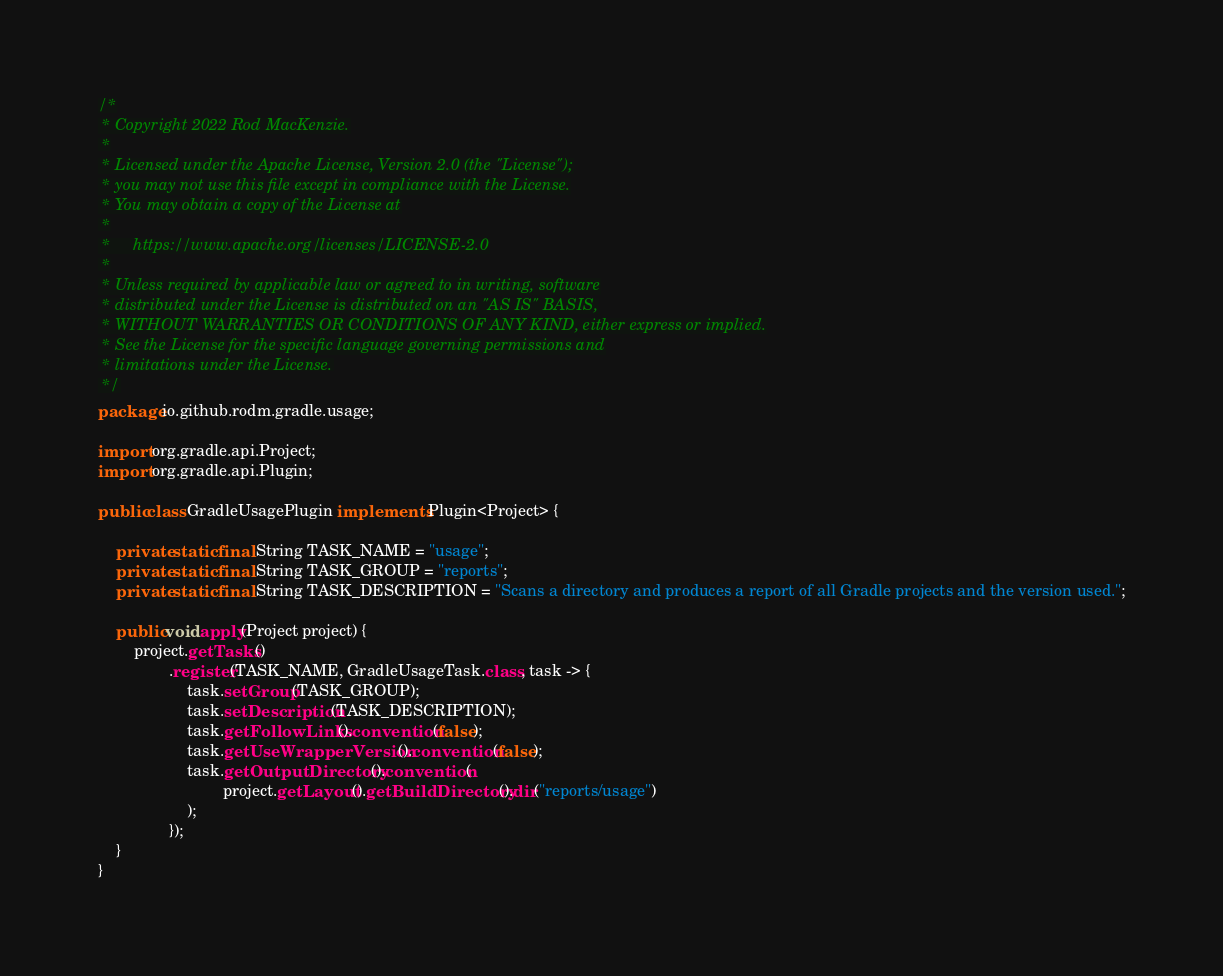Convert code to text. <code><loc_0><loc_0><loc_500><loc_500><_Java_>/*
 * Copyright 2022 Rod MacKenzie.
 *
 * Licensed under the Apache License, Version 2.0 (the "License");
 * you may not use this file except in compliance with the License.
 * You may obtain a copy of the License at
 *
 *     https://www.apache.org/licenses/LICENSE-2.0
 *
 * Unless required by applicable law or agreed to in writing, software
 * distributed under the License is distributed on an "AS IS" BASIS,
 * WITHOUT WARRANTIES OR CONDITIONS OF ANY KIND, either express or implied.
 * See the License for the specific language governing permissions and
 * limitations under the License.
 */
package io.github.rodm.gradle.usage;

import org.gradle.api.Project;
import org.gradle.api.Plugin;

public class GradleUsagePlugin implements Plugin<Project> {

    private static final String TASK_NAME = "usage";
    private static final String TASK_GROUP = "reports";
    private static final String TASK_DESCRIPTION = "Scans a directory and produces a report of all Gradle projects and the version used.";

    public void apply(Project project) {
        project.getTasks()
                .register(TASK_NAME, GradleUsageTask.class, task -> {
                    task.setGroup(TASK_GROUP);
                    task.setDescription(TASK_DESCRIPTION);
                    task.getFollowLinks().convention(false);
                    task.getUseWrapperVersion().convention(false);
                    task.getOutputDirectory().convention(
                            project.getLayout().getBuildDirectory().dir("reports/usage")
                    );
                });
    }
}
</code> 